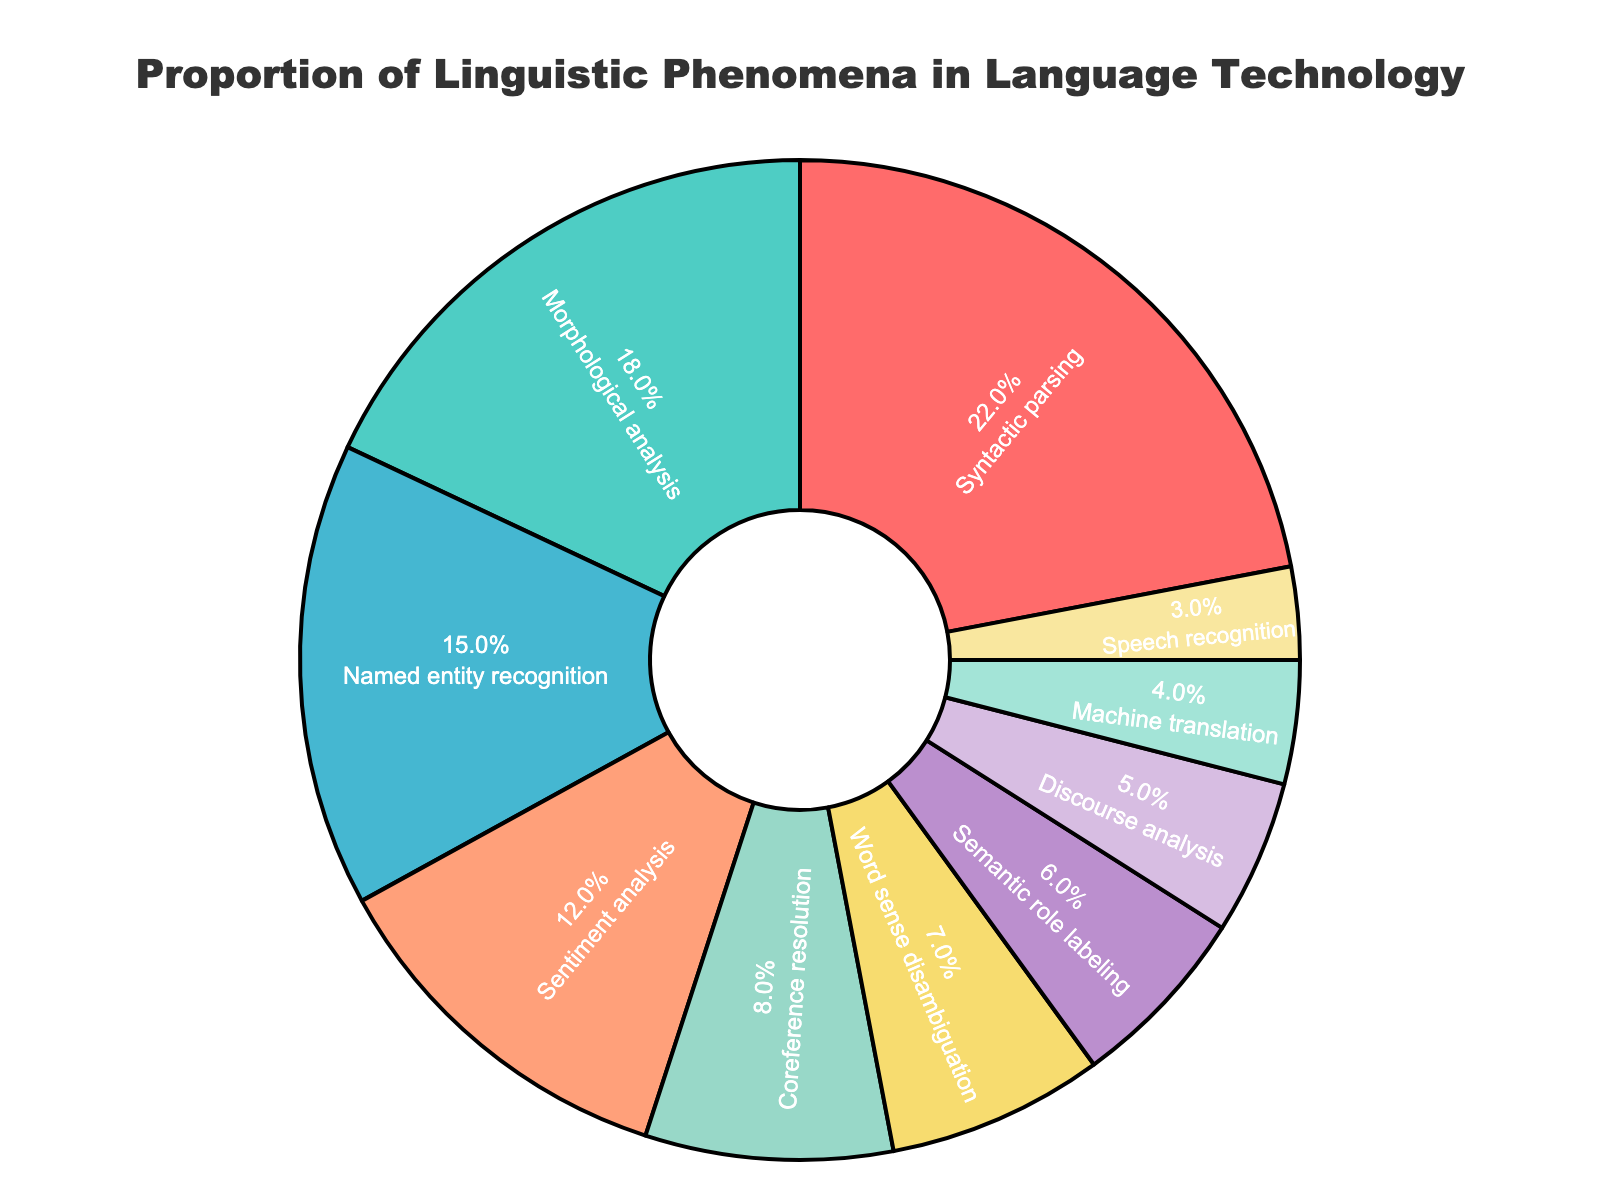Which linguistic phenomenon has the highest proportion in language technology applications? The largest segment of the pie chart corresponds to Syntactic parsing.
Answer: Syntactic parsing What is the proportion of Named entity recognition relative to Syntactic parsing? The proportion of Named entity recognition is 15%, while that of Syntactic parsing is 22%. The relative proportion is obtained by dividing 15 by 22.
Answer: ~68.2% How much more common is Syntactic parsing than Discourse analysis? Syntactic parsing accounts for 22%, while Discourse analysis accounts for 5%. The difference is 22 - 5.
Answer: 17% Which linguistic phenomenon is least addressed in language technology applications? The smallest segment in the pie chart corresponds to Speech recognition.
Answer: Speech recognition What is the combined percentage for Morphological analysis and Machine translation? Morphological analysis accounts for 18% and Machine translation 4%. The combined percentage is 18 + 4.
Answer: 22% How does Sentiment analysis compare to Named entity recognition in terms of proportion? Sentiment analysis accounts for 12%, while Named entity recognition accounts for 15%. Sentiment analysis is 3% less than Named entity recognition.
Answer: 3% less Rank the top three linguistic phenomena by their proportions. The top three phenomena by proportion are Syntactic parsing (22%), Morphological analysis (18%), and Named entity recognition (15%).
Answer: 1. Syntactic parsing 2. Morphological analysis 3. Named entity recognition What is the total percentage covered by the top four linguistic phenomena? The top four phenomena are Syntactic parsing (22%), Morphological analysis (18%), Named entity recognition (15%), and Sentiment analysis (12%). The total is 22 + 18 + 15 + 12.
Answer: 67% How does Coreference resolution compare visually to Word sense disambiguation? Coreference resolution and Word sense disambiguation have adjacent segments. Coreference resolution has a slightly larger area (8%) compared to Word sense disambiguation (7%).
Answer: Coreference resolution is larger What is the percentage gap between Word sense disambiguation and Machine translation? Word sense disambiguation is 7% and Machine translation is 4%. The gap is 7 - 4.
Answer: 3% 